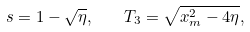Convert formula to latex. <formula><loc_0><loc_0><loc_500><loc_500>s = 1 - \sqrt { \eta } , \quad T _ { 3 } = \sqrt { x _ { m } ^ { 2 } - 4 \eta } ,</formula> 